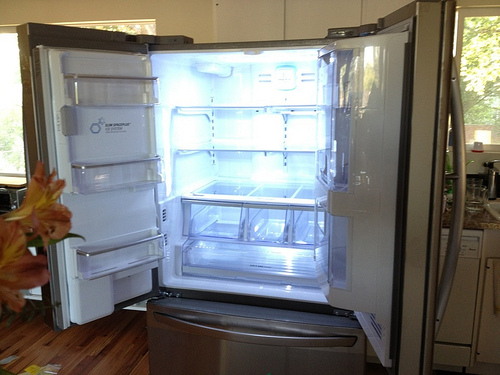Please provide a short description for this region: [0.18, 0.37, 0.27, 0.41]. This region features a variety of magnets and notes affixed to the refrigerator door, reflecting the household's personal touches and daily reminders. 